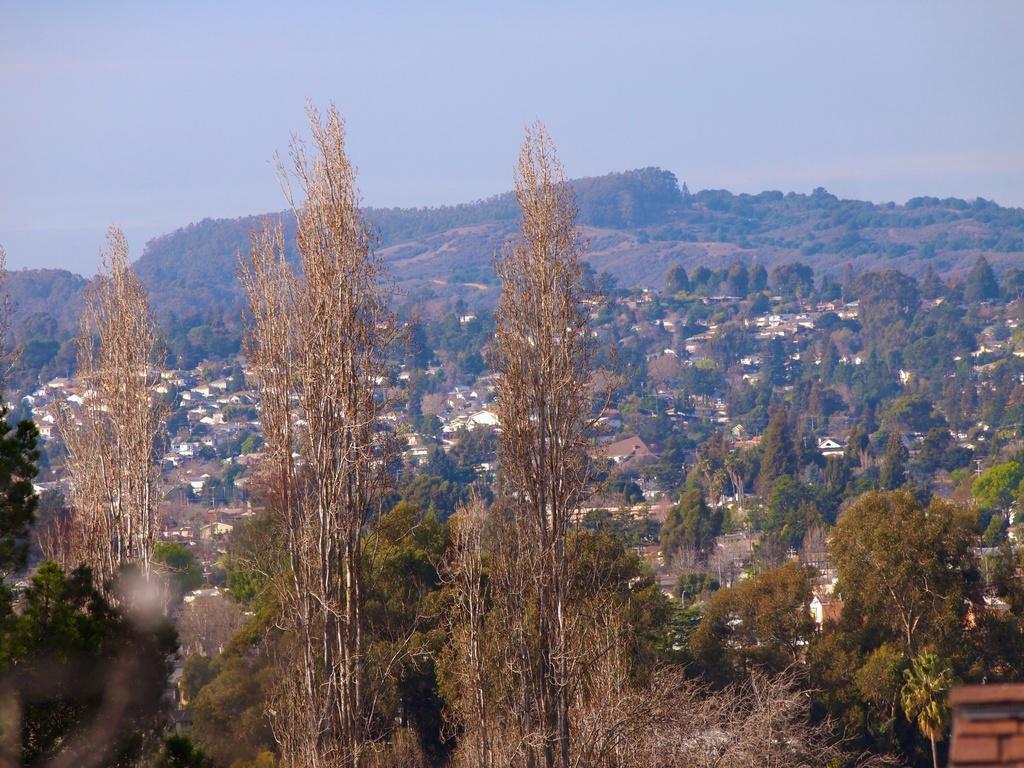Can you describe this image briefly? In this image, we can see some trees. There is a hill in the middle of the image. There is a sky at the top of the image. 